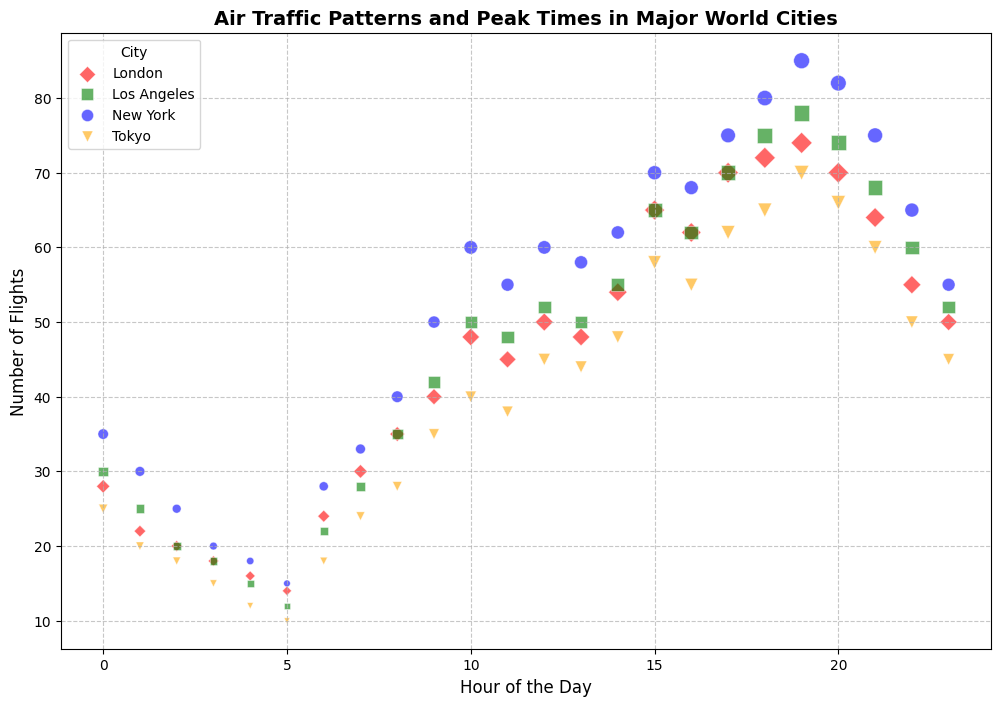What city has the number of flights peaking at 85? To identify the city with the highest peak, look for the highest point on the y-axis. New York has the highest peak with 85 flights at 19:00
Answer: New York Which city has the lowest number of flights at midnight? To find the city with the lowest number of flights at midnight, compare the y-values of the points located at the x-value (Hour) of 0. Tokyo has 25 flights, the lowest at midnight
Answer: Tokyo What is the difference in the maximum number of flights between New York and Los Angeles? Find the peak value (highest y-value) of the number of flights for both cities. New York peaks at 85 flights, and Los Angeles peaks at 78 flights. The difference is 85 - 78
Answer: 7 Which city has the highest concentration of flights during the evening (18:00 to 21:00)? To determine this, examine the density of points (number of flights) for each city between the hours of 18 to 21 on the x-axis. New York shows the highest concentration with multiple high-valued points (80, 85, 82, 75)
Answer: New York Compare the number of flights between Tokyo and London at 10:00. Which city has more flights and by how much? At 10:00, London has 48 flights while Tokyo has 40 flights. London has 8 more flights than Tokyo
Answer: London by 8 What color represents flights from London and how can we interpret the number of flights visually? The color for London is red. Red markers visually represent flights from London, and the size of the marker relates to the number of passengers, giving a visual sense of traffic
Answer: Red During which hour does Los Angeles experience its peak number of flights, and what is this number? The highest value for Los Angeles on the y-axis represents the peak number of flights, which occurs at 19:00 with 78 flights
Answer: 19:00, 78 How does the range of flights in New York compare to Tokyo? Determine the difference between the peak and the lowest number of flights for each city. New York ranges from 85 (peak) to 15 (minimum), giving a range of 70. Tokyo ranges from 70 to 10, giving a range of 60
Answer: New York has a range of 70, Tokyo has a range of 60 What is the pattern of flights over the day in London, and what general trend do you see? The pattern in London shows an increase in flights throughout the morning, peaking around 15:00 to 19:00, and then a decline towards midnight. This trend outlines a mid-day peak
Answer: Mid-day peak from 15:00 to 19:00 How does the concentration of flights in Tokyo at noon compare to New York? At noon (12:00 on the x-axis), compare the number of flights for Tokyo and New York. Tokyo has 45 flights whereas New York has 60 flights. New York has a higher concentration of flights
Answer: New York has 15 more flights at noon 